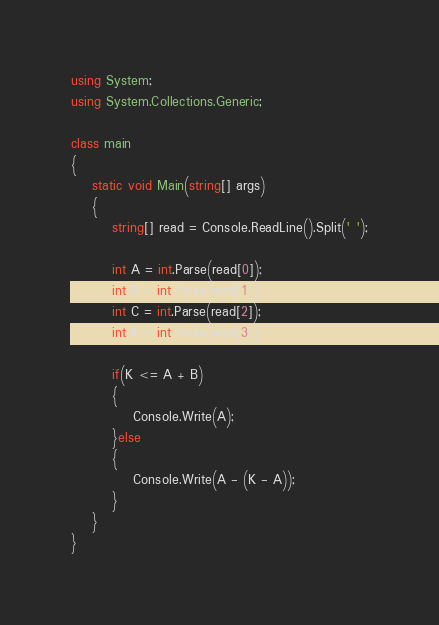<code> <loc_0><loc_0><loc_500><loc_500><_C#_>using System;
using System.Collections.Generic;

class main
{
    static void Main(string[] args)
    {
        string[] read = Console.ReadLine().Split(' ');

        int A = int.Parse(read[0]);
        int B = int.Parse(read[1]);
        int C = int.Parse(read[2]);
        int K = int.Parse(read[3]);

        if(K <= A + B)
        {
            Console.Write(A);
        }else
        {
            Console.Write(A - (K - A));
        }
    }
}

</code> 